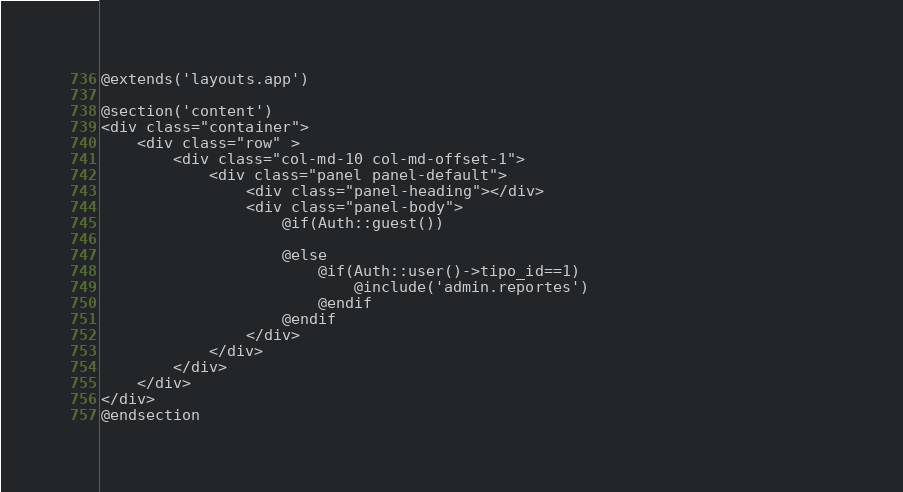<code> <loc_0><loc_0><loc_500><loc_500><_PHP_>@extends('layouts.app')

@section('content')
<div class="container">
    <div class="row" >
        <div class="col-md-10 col-md-offset-1">
            <div class="panel panel-default">
                <div class="panel-heading"></div>
                <div class="panel-body">
                    @if(Auth::guest())

                    @else
                        @if(Auth::user()->tipo_id==1)                            
                            @include('admin.reportes')
                        @endif
                    @endif
                </div>
            </div>
        </div>
    </div>
</div>
@endsection
</code> 